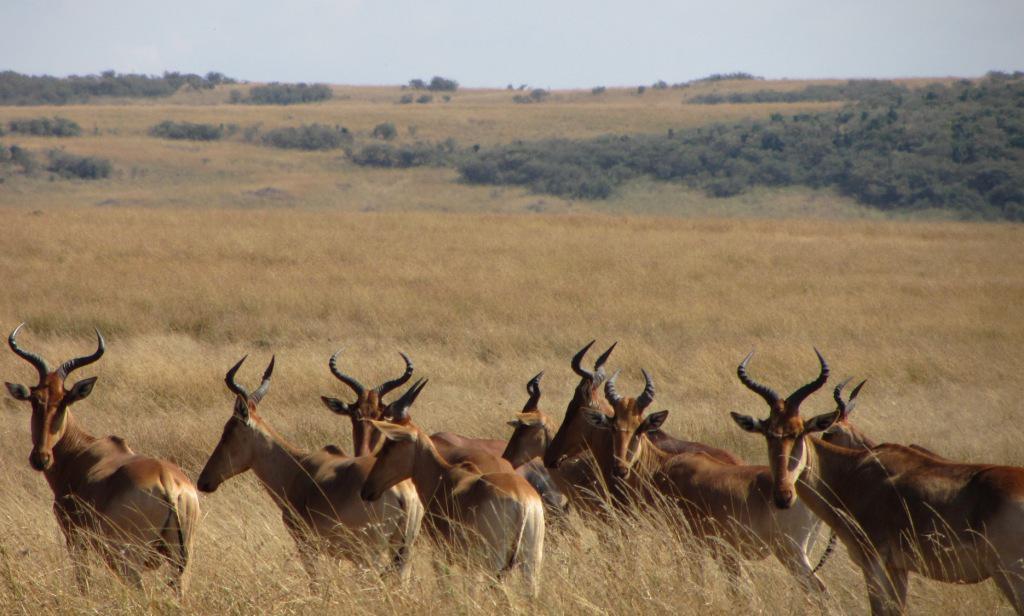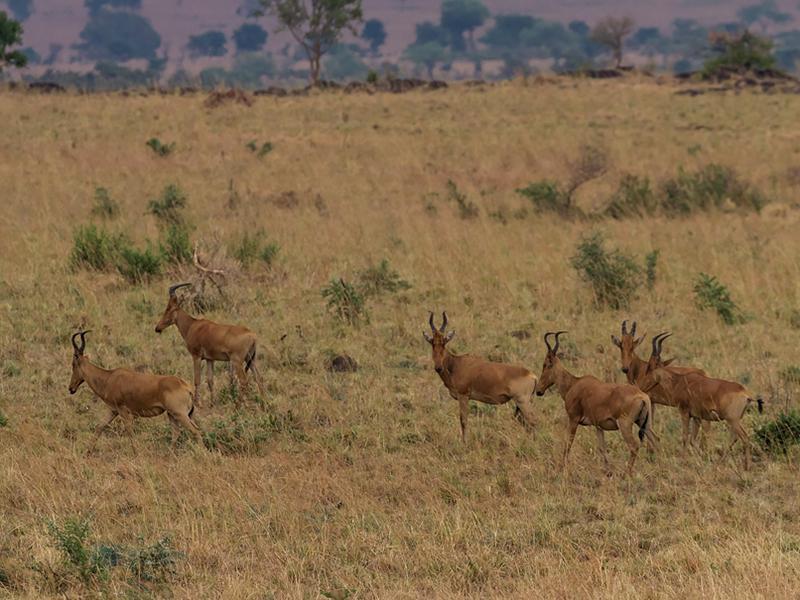The first image is the image on the left, the second image is the image on the right. Examine the images to the left and right. Is the description "An image includes a horned animal that is bounding with front legs fully off the ground." accurate? Answer yes or no. No. The first image is the image on the left, the second image is the image on the right. For the images shown, is this caption "At least one antelope has its front legs int he air." true? Answer yes or no. No. The first image is the image on the left, the second image is the image on the right. Examine the images to the left and right. Is the description "At least two horned animals are standing with their rears directly facing the camera, showing very dark tails on pale hinds." accurate? Answer yes or no. No. The first image is the image on the left, the second image is the image on the right. Evaluate the accuracy of this statement regarding the images: "There are at most 6 antelopes in at least one of the images.". Is it true? Answer yes or no. Yes. 